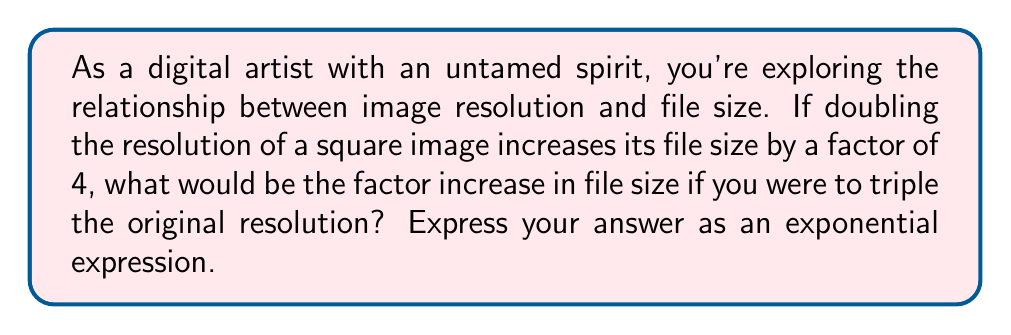Solve this math problem. Let's approach this step-by-step:

1) First, we need to understand the relationship between resolution and file size:
   - Doubling the resolution increases the file size by a factor of 4
   - This suggests an exponential relationship

2) Let's express this mathematically:
   - If we denote the original resolution as $x$, then doubling it would be $2x$
   - The file size increase is $2^2 = 4$

3) We can generalize this relationship:
   - For a square image, if we multiply the resolution by $n$, the file size increases by a factor of $n^2$

4) This is because:
   - A square image has two dimensions (width and height)
   - Increasing each dimension by a factor of $n$ results in $n * n = n^2$ more pixels

5) Now, for our specific question:
   - We're tripling the original resolution
   - This means $n = 3$

6) Therefore, the factor increase in file size would be:
   $3^2 = 9$

This exponential relationship $(n^2)$ reflects how quickly file sizes can grow with increases in resolution, a crucial consideration for digital artists balancing image quality and storage constraints.
Answer: $3^2$ 